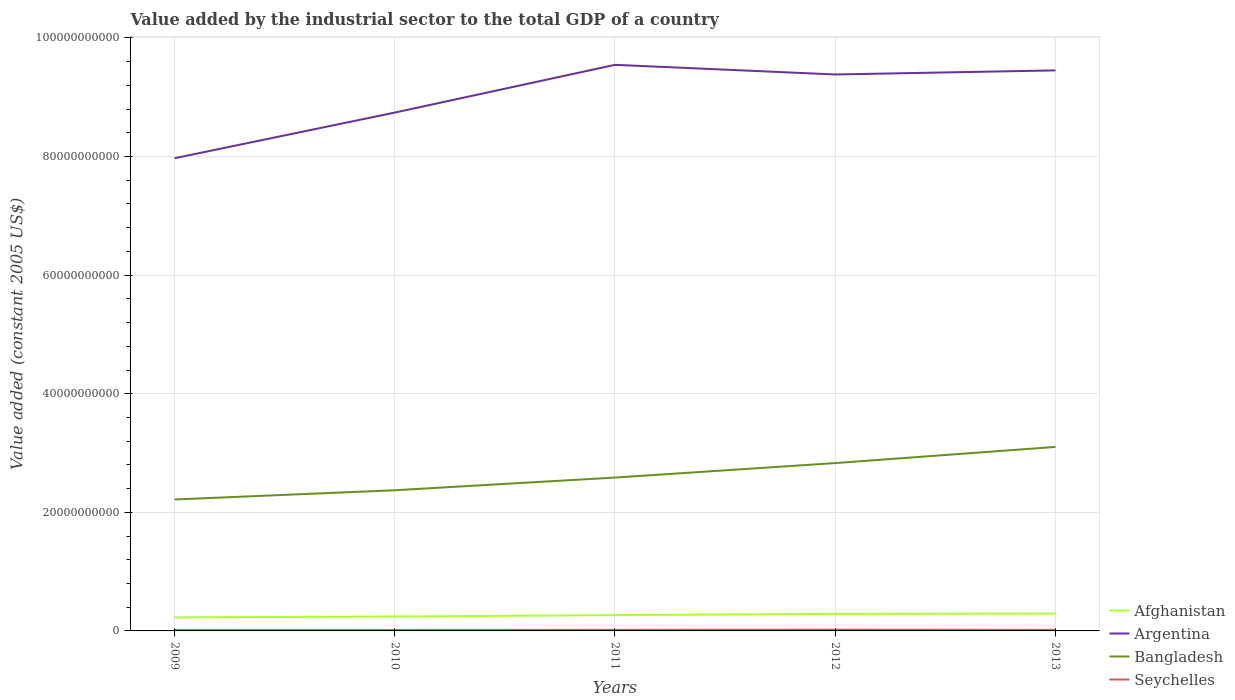How many different coloured lines are there?
Keep it short and to the point. 4. Across all years, what is the maximum value added by the industrial sector in Argentina?
Provide a short and direct response. 7.97e+1. In which year was the value added by the industrial sector in Bangladesh maximum?
Offer a terse response. 2009. What is the total value added by the industrial sector in Bangladesh in the graph?
Provide a succinct answer. -4.58e+09. What is the difference between the highest and the second highest value added by the industrial sector in Bangladesh?
Keep it short and to the point. 8.87e+09. How many years are there in the graph?
Provide a succinct answer. 5. Does the graph contain any zero values?
Your answer should be compact. No. Where does the legend appear in the graph?
Your response must be concise. Bottom right. How many legend labels are there?
Make the answer very short. 4. How are the legend labels stacked?
Make the answer very short. Vertical. What is the title of the graph?
Your answer should be compact. Value added by the industrial sector to the total GDP of a country. What is the label or title of the Y-axis?
Keep it short and to the point. Value added (constant 2005 US$). What is the Value added (constant 2005 US$) in Afghanistan in 2009?
Keep it short and to the point. 2.29e+09. What is the Value added (constant 2005 US$) in Argentina in 2009?
Your answer should be compact. 7.97e+1. What is the Value added (constant 2005 US$) of Bangladesh in 2009?
Give a very brief answer. 2.22e+1. What is the Value added (constant 2005 US$) in Seychelles in 2009?
Keep it short and to the point. 1.54e+08. What is the Value added (constant 2005 US$) in Afghanistan in 2010?
Your answer should be compact. 2.43e+09. What is the Value added (constant 2005 US$) of Argentina in 2010?
Your response must be concise. 8.74e+1. What is the Value added (constant 2005 US$) in Bangladesh in 2010?
Offer a terse response. 2.37e+1. What is the Value added (constant 2005 US$) in Seychelles in 2010?
Offer a very short reply. 1.59e+08. What is the Value added (constant 2005 US$) of Afghanistan in 2011?
Give a very brief answer. 2.67e+09. What is the Value added (constant 2005 US$) in Argentina in 2011?
Your answer should be very brief. 9.55e+1. What is the Value added (constant 2005 US$) in Bangladesh in 2011?
Keep it short and to the point. 2.59e+1. What is the Value added (constant 2005 US$) of Seychelles in 2011?
Ensure brevity in your answer.  1.84e+08. What is the Value added (constant 2005 US$) in Afghanistan in 2012?
Keep it short and to the point. 2.87e+09. What is the Value added (constant 2005 US$) of Argentina in 2012?
Your response must be concise. 9.38e+1. What is the Value added (constant 2005 US$) of Bangladesh in 2012?
Ensure brevity in your answer.  2.83e+1. What is the Value added (constant 2005 US$) in Seychelles in 2012?
Your answer should be compact. 2.18e+08. What is the Value added (constant 2005 US$) in Afghanistan in 2013?
Make the answer very short. 2.92e+09. What is the Value added (constant 2005 US$) of Argentina in 2013?
Your answer should be very brief. 9.45e+1. What is the Value added (constant 2005 US$) of Bangladesh in 2013?
Provide a succinct answer. 3.10e+1. What is the Value added (constant 2005 US$) in Seychelles in 2013?
Give a very brief answer. 1.75e+08. Across all years, what is the maximum Value added (constant 2005 US$) in Afghanistan?
Provide a succinct answer. 2.92e+09. Across all years, what is the maximum Value added (constant 2005 US$) of Argentina?
Give a very brief answer. 9.55e+1. Across all years, what is the maximum Value added (constant 2005 US$) in Bangladesh?
Your response must be concise. 3.10e+1. Across all years, what is the maximum Value added (constant 2005 US$) in Seychelles?
Your response must be concise. 2.18e+08. Across all years, what is the minimum Value added (constant 2005 US$) in Afghanistan?
Provide a short and direct response. 2.29e+09. Across all years, what is the minimum Value added (constant 2005 US$) in Argentina?
Your answer should be compact. 7.97e+1. Across all years, what is the minimum Value added (constant 2005 US$) in Bangladesh?
Offer a very short reply. 2.22e+1. Across all years, what is the minimum Value added (constant 2005 US$) of Seychelles?
Your answer should be very brief. 1.54e+08. What is the total Value added (constant 2005 US$) of Afghanistan in the graph?
Make the answer very short. 1.32e+1. What is the total Value added (constant 2005 US$) in Argentina in the graph?
Ensure brevity in your answer.  4.51e+11. What is the total Value added (constant 2005 US$) in Bangladesh in the graph?
Make the answer very short. 1.31e+11. What is the total Value added (constant 2005 US$) of Seychelles in the graph?
Offer a terse response. 8.90e+08. What is the difference between the Value added (constant 2005 US$) of Afghanistan in 2009 and that in 2010?
Your response must be concise. -1.43e+08. What is the difference between the Value added (constant 2005 US$) of Argentina in 2009 and that in 2010?
Provide a succinct answer. -7.70e+09. What is the difference between the Value added (constant 2005 US$) of Bangladesh in 2009 and that in 2010?
Your answer should be very brief. -1.56e+09. What is the difference between the Value added (constant 2005 US$) in Seychelles in 2009 and that in 2010?
Offer a very short reply. -5.25e+06. What is the difference between the Value added (constant 2005 US$) of Afghanistan in 2009 and that in 2011?
Your answer should be compact. -3.81e+08. What is the difference between the Value added (constant 2005 US$) in Argentina in 2009 and that in 2011?
Provide a short and direct response. -1.57e+1. What is the difference between the Value added (constant 2005 US$) of Bangladesh in 2009 and that in 2011?
Your response must be concise. -3.70e+09. What is the difference between the Value added (constant 2005 US$) of Seychelles in 2009 and that in 2011?
Your answer should be compact. -2.95e+07. What is the difference between the Value added (constant 2005 US$) in Afghanistan in 2009 and that in 2012?
Your answer should be very brief. -5.88e+08. What is the difference between the Value added (constant 2005 US$) in Argentina in 2009 and that in 2012?
Ensure brevity in your answer.  -1.41e+1. What is the difference between the Value added (constant 2005 US$) in Bangladesh in 2009 and that in 2012?
Your answer should be compact. -6.14e+09. What is the difference between the Value added (constant 2005 US$) of Seychelles in 2009 and that in 2012?
Provide a succinct answer. -6.41e+07. What is the difference between the Value added (constant 2005 US$) of Afghanistan in 2009 and that in 2013?
Your response must be concise. -6.38e+08. What is the difference between the Value added (constant 2005 US$) of Argentina in 2009 and that in 2013?
Ensure brevity in your answer.  -1.48e+1. What is the difference between the Value added (constant 2005 US$) in Bangladesh in 2009 and that in 2013?
Give a very brief answer. -8.87e+09. What is the difference between the Value added (constant 2005 US$) in Seychelles in 2009 and that in 2013?
Your response must be concise. -2.12e+07. What is the difference between the Value added (constant 2005 US$) of Afghanistan in 2010 and that in 2011?
Give a very brief answer. -2.38e+08. What is the difference between the Value added (constant 2005 US$) of Argentina in 2010 and that in 2011?
Your response must be concise. -8.05e+09. What is the difference between the Value added (constant 2005 US$) of Bangladesh in 2010 and that in 2011?
Provide a succinct answer. -2.14e+09. What is the difference between the Value added (constant 2005 US$) in Seychelles in 2010 and that in 2011?
Give a very brief answer. -2.43e+07. What is the difference between the Value added (constant 2005 US$) of Afghanistan in 2010 and that in 2012?
Provide a short and direct response. -4.45e+08. What is the difference between the Value added (constant 2005 US$) in Argentina in 2010 and that in 2012?
Give a very brief answer. -6.43e+09. What is the difference between the Value added (constant 2005 US$) of Bangladesh in 2010 and that in 2012?
Your answer should be compact. -4.58e+09. What is the difference between the Value added (constant 2005 US$) of Seychelles in 2010 and that in 2012?
Your response must be concise. -5.88e+07. What is the difference between the Value added (constant 2005 US$) in Afghanistan in 2010 and that in 2013?
Give a very brief answer. -4.95e+08. What is the difference between the Value added (constant 2005 US$) of Argentina in 2010 and that in 2013?
Ensure brevity in your answer.  -7.11e+09. What is the difference between the Value added (constant 2005 US$) of Bangladesh in 2010 and that in 2013?
Provide a succinct answer. -7.31e+09. What is the difference between the Value added (constant 2005 US$) of Seychelles in 2010 and that in 2013?
Keep it short and to the point. -1.59e+07. What is the difference between the Value added (constant 2005 US$) in Afghanistan in 2011 and that in 2012?
Make the answer very short. -2.07e+08. What is the difference between the Value added (constant 2005 US$) in Argentina in 2011 and that in 2012?
Keep it short and to the point. 1.63e+09. What is the difference between the Value added (constant 2005 US$) in Bangladesh in 2011 and that in 2012?
Give a very brief answer. -2.44e+09. What is the difference between the Value added (constant 2005 US$) of Seychelles in 2011 and that in 2012?
Ensure brevity in your answer.  -3.45e+07. What is the difference between the Value added (constant 2005 US$) of Afghanistan in 2011 and that in 2013?
Ensure brevity in your answer.  -2.57e+08. What is the difference between the Value added (constant 2005 US$) of Argentina in 2011 and that in 2013?
Keep it short and to the point. 9.36e+08. What is the difference between the Value added (constant 2005 US$) in Bangladesh in 2011 and that in 2013?
Provide a short and direct response. -5.17e+09. What is the difference between the Value added (constant 2005 US$) of Seychelles in 2011 and that in 2013?
Offer a terse response. 8.34e+06. What is the difference between the Value added (constant 2005 US$) in Afghanistan in 2012 and that in 2013?
Your answer should be very brief. -5.03e+07. What is the difference between the Value added (constant 2005 US$) in Argentina in 2012 and that in 2013?
Provide a short and direct response. -6.89e+08. What is the difference between the Value added (constant 2005 US$) of Bangladesh in 2012 and that in 2013?
Your answer should be very brief. -2.73e+09. What is the difference between the Value added (constant 2005 US$) in Seychelles in 2012 and that in 2013?
Your answer should be compact. 4.29e+07. What is the difference between the Value added (constant 2005 US$) in Afghanistan in 2009 and the Value added (constant 2005 US$) in Argentina in 2010?
Provide a short and direct response. -8.51e+1. What is the difference between the Value added (constant 2005 US$) of Afghanistan in 2009 and the Value added (constant 2005 US$) of Bangladesh in 2010?
Give a very brief answer. -2.14e+1. What is the difference between the Value added (constant 2005 US$) of Afghanistan in 2009 and the Value added (constant 2005 US$) of Seychelles in 2010?
Your answer should be very brief. 2.13e+09. What is the difference between the Value added (constant 2005 US$) of Argentina in 2009 and the Value added (constant 2005 US$) of Bangladesh in 2010?
Ensure brevity in your answer.  5.60e+1. What is the difference between the Value added (constant 2005 US$) of Argentina in 2009 and the Value added (constant 2005 US$) of Seychelles in 2010?
Provide a succinct answer. 7.96e+1. What is the difference between the Value added (constant 2005 US$) in Bangladesh in 2009 and the Value added (constant 2005 US$) in Seychelles in 2010?
Your response must be concise. 2.20e+1. What is the difference between the Value added (constant 2005 US$) of Afghanistan in 2009 and the Value added (constant 2005 US$) of Argentina in 2011?
Provide a short and direct response. -9.32e+1. What is the difference between the Value added (constant 2005 US$) in Afghanistan in 2009 and the Value added (constant 2005 US$) in Bangladesh in 2011?
Make the answer very short. -2.36e+1. What is the difference between the Value added (constant 2005 US$) in Afghanistan in 2009 and the Value added (constant 2005 US$) in Seychelles in 2011?
Provide a short and direct response. 2.10e+09. What is the difference between the Value added (constant 2005 US$) in Argentina in 2009 and the Value added (constant 2005 US$) in Bangladesh in 2011?
Offer a terse response. 5.39e+1. What is the difference between the Value added (constant 2005 US$) of Argentina in 2009 and the Value added (constant 2005 US$) of Seychelles in 2011?
Your response must be concise. 7.95e+1. What is the difference between the Value added (constant 2005 US$) of Bangladesh in 2009 and the Value added (constant 2005 US$) of Seychelles in 2011?
Provide a succinct answer. 2.20e+1. What is the difference between the Value added (constant 2005 US$) of Afghanistan in 2009 and the Value added (constant 2005 US$) of Argentina in 2012?
Make the answer very short. -9.16e+1. What is the difference between the Value added (constant 2005 US$) in Afghanistan in 2009 and the Value added (constant 2005 US$) in Bangladesh in 2012?
Keep it short and to the point. -2.60e+1. What is the difference between the Value added (constant 2005 US$) in Afghanistan in 2009 and the Value added (constant 2005 US$) in Seychelles in 2012?
Give a very brief answer. 2.07e+09. What is the difference between the Value added (constant 2005 US$) of Argentina in 2009 and the Value added (constant 2005 US$) of Bangladesh in 2012?
Make the answer very short. 5.14e+1. What is the difference between the Value added (constant 2005 US$) in Argentina in 2009 and the Value added (constant 2005 US$) in Seychelles in 2012?
Provide a succinct answer. 7.95e+1. What is the difference between the Value added (constant 2005 US$) in Bangladesh in 2009 and the Value added (constant 2005 US$) in Seychelles in 2012?
Give a very brief answer. 2.19e+1. What is the difference between the Value added (constant 2005 US$) of Afghanistan in 2009 and the Value added (constant 2005 US$) of Argentina in 2013?
Keep it short and to the point. -9.22e+1. What is the difference between the Value added (constant 2005 US$) in Afghanistan in 2009 and the Value added (constant 2005 US$) in Bangladesh in 2013?
Provide a short and direct response. -2.87e+1. What is the difference between the Value added (constant 2005 US$) in Afghanistan in 2009 and the Value added (constant 2005 US$) in Seychelles in 2013?
Your response must be concise. 2.11e+09. What is the difference between the Value added (constant 2005 US$) of Argentina in 2009 and the Value added (constant 2005 US$) of Bangladesh in 2013?
Ensure brevity in your answer.  4.87e+1. What is the difference between the Value added (constant 2005 US$) of Argentina in 2009 and the Value added (constant 2005 US$) of Seychelles in 2013?
Offer a terse response. 7.95e+1. What is the difference between the Value added (constant 2005 US$) of Bangladesh in 2009 and the Value added (constant 2005 US$) of Seychelles in 2013?
Your response must be concise. 2.20e+1. What is the difference between the Value added (constant 2005 US$) in Afghanistan in 2010 and the Value added (constant 2005 US$) in Argentina in 2011?
Your answer should be very brief. -9.30e+1. What is the difference between the Value added (constant 2005 US$) in Afghanistan in 2010 and the Value added (constant 2005 US$) in Bangladesh in 2011?
Provide a succinct answer. -2.34e+1. What is the difference between the Value added (constant 2005 US$) in Afghanistan in 2010 and the Value added (constant 2005 US$) in Seychelles in 2011?
Provide a short and direct response. 2.24e+09. What is the difference between the Value added (constant 2005 US$) of Argentina in 2010 and the Value added (constant 2005 US$) of Bangladesh in 2011?
Ensure brevity in your answer.  6.16e+1. What is the difference between the Value added (constant 2005 US$) of Argentina in 2010 and the Value added (constant 2005 US$) of Seychelles in 2011?
Keep it short and to the point. 8.72e+1. What is the difference between the Value added (constant 2005 US$) of Bangladesh in 2010 and the Value added (constant 2005 US$) of Seychelles in 2011?
Make the answer very short. 2.35e+1. What is the difference between the Value added (constant 2005 US$) of Afghanistan in 2010 and the Value added (constant 2005 US$) of Argentina in 2012?
Your answer should be very brief. -9.14e+1. What is the difference between the Value added (constant 2005 US$) in Afghanistan in 2010 and the Value added (constant 2005 US$) in Bangladesh in 2012?
Keep it short and to the point. -2.59e+1. What is the difference between the Value added (constant 2005 US$) in Afghanistan in 2010 and the Value added (constant 2005 US$) in Seychelles in 2012?
Your response must be concise. 2.21e+09. What is the difference between the Value added (constant 2005 US$) in Argentina in 2010 and the Value added (constant 2005 US$) in Bangladesh in 2012?
Provide a short and direct response. 5.91e+1. What is the difference between the Value added (constant 2005 US$) in Argentina in 2010 and the Value added (constant 2005 US$) in Seychelles in 2012?
Your answer should be very brief. 8.72e+1. What is the difference between the Value added (constant 2005 US$) in Bangladesh in 2010 and the Value added (constant 2005 US$) in Seychelles in 2012?
Offer a terse response. 2.35e+1. What is the difference between the Value added (constant 2005 US$) of Afghanistan in 2010 and the Value added (constant 2005 US$) of Argentina in 2013?
Your answer should be compact. -9.21e+1. What is the difference between the Value added (constant 2005 US$) of Afghanistan in 2010 and the Value added (constant 2005 US$) of Bangladesh in 2013?
Your answer should be compact. -2.86e+1. What is the difference between the Value added (constant 2005 US$) of Afghanistan in 2010 and the Value added (constant 2005 US$) of Seychelles in 2013?
Your answer should be very brief. 2.25e+09. What is the difference between the Value added (constant 2005 US$) in Argentina in 2010 and the Value added (constant 2005 US$) in Bangladesh in 2013?
Your answer should be very brief. 5.64e+1. What is the difference between the Value added (constant 2005 US$) of Argentina in 2010 and the Value added (constant 2005 US$) of Seychelles in 2013?
Give a very brief answer. 8.72e+1. What is the difference between the Value added (constant 2005 US$) of Bangladesh in 2010 and the Value added (constant 2005 US$) of Seychelles in 2013?
Offer a very short reply. 2.35e+1. What is the difference between the Value added (constant 2005 US$) in Afghanistan in 2011 and the Value added (constant 2005 US$) in Argentina in 2012?
Offer a very short reply. -9.12e+1. What is the difference between the Value added (constant 2005 US$) of Afghanistan in 2011 and the Value added (constant 2005 US$) of Bangladesh in 2012?
Give a very brief answer. -2.56e+1. What is the difference between the Value added (constant 2005 US$) of Afghanistan in 2011 and the Value added (constant 2005 US$) of Seychelles in 2012?
Your answer should be compact. 2.45e+09. What is the difference between the Value added (constant 2005 US$) in Argentina in 2011 and the Value added (constant 2005 US$) in Bangladesh in 2012?
Offer a terse response. 6.72e+1. What is the difference between the Value added (constant 2005 US$) of Argentina in 2011 and the Value added (constant 2005 US$) of Seychelles in 2012?
Make the answer very short. 9.52e+1. What is the difference between the Value added (constant 2005 US$) in Bangladesh in 2011 and the Value added (constant 2005 US$) in Seychelles in 2012?
Your answer should be very brief. 2.56e+1. What is the difference between the Value added (constant 2005 US$) in Afghanistan in 2011 and the Value added (constant 2005 US$) in Argentina in 2013?
Offer a terse response. -9.19e+1. What is the difference between the Value added (constant 2005 US$) in Afghanistan in 2011 and the Value added (constant 2005 US$) in Bangladesh in 2013?
Offer a terse response. -2.84e+1. What is the difference between the Value added (constant 2005 US$) in Afghanistan in 2011 and the Value added (constant 2005 US$) in Seychelles in 2013?
Offer a terse response. 2.49e+09. What is the difference between the Value added (constant 2005 US$) in Argentina in 2011 and the Value added (constant 2005 US$) in Bangladesh in 2013?
Your response must be concise. 6.44e+1. What is the difference between the Value added (constant 2005 US$) of Argentina in 2011 and the Value added (constant 2005 US$) of Seychelles in 2013?
Keep it short and to the point. 9.53e+1. What is the difference between the Value added (constant 2005 US$) of Bangladesh in 2011 and the Value added (constant 2005 US$) of Seychelles in 2013?
Provide a succinct answer. 2.57e+1. What is the difference between the Value added (constant 2005 US$) of Afghanistan in 2012 and the Value added (constant 2005 US$) of Argentina in 2013?
Provide a short and direct response. -9.17e+1. What is the difference between the Value added (constant 2005 US$) of Afghanistan in 2012 and the Value added (constant 2005 US$) of Bangladesh in 2013?
Provide a short and direct response. -2.82e+1. What is the difference between the Value added (constant 2005 US$) of Afghanistan in 2012 and the Value added (constant 2005 US$) of Seychelles in 2013?
Make the answer very short. 2.70e+09. What is the difference between the Value added (constant 2005 US$) of Argentina in 2012 and the Value added (constant 2005 US$) of Bangladesh in 2013?
Provide a succinct answer. 6.28e+1. What is the difference between the Value added (constant 2005 US$) of Argentina in 2012 and the Value added (constant 2005 US$) of Seychelles in 2013?
Ensure brevity in your answer.  9.37e+1. What is the difference between the Value added (constant 2005 US$) of Bangladesh in 2012 and the Value added (constant 2005 US$) of Seychelles in 2013?
Make the answer very short. 2.81e+1. What is the average Value added (constant 2005 US$) of Afghanistan per year?
Make the answer very short. 2.64e+09. What is the average Value added (constant 2005 US$) of Argentina per year?
Offer a very short reply. 9.02e+1. What is the average Value added (constant 2005 US$) of Bangladesh per year?
Provide a succinct answer. 2.62e+1. What is the average Value added (constant 2005 US$) in Seychelles per year?
Provide a short and direct response. 1.78e+08. In the year 2009, what is the difference between the Value added (constant 2005 US$) of Afghanistan and Value added (constant 2005 US$) of Argentina?
Make the answer very short. -7.74e+1. In the year 2009, what is the difference between the Value added (constant 2005 US$) of Afghanistan and Value added (constant 2005 US$) of Bangladesh?
Offer a very short reply. -1.99e+1. In the year 2009, what is the difference between the Value added (constant 2005 US$) in Afghanistan and Value added (constant 2005 US$) in Seychelles?
Your answer should be very brief. 2.13e+09. In the year 2009, what is the difference between the Value added (constant 2005 US$) of Argentina and Value added (constant 2005 US$) of Bangladesh?
Give a very brief answer. 5.76e+1. In the year 2009, what is the difference between the Value added (constant 2005 US$) of Argentina and Value added (constant 2005 US$) of Seychelles?
Keep it short and to the point. 7.96e+1. In the year 2009, what is the difference between the Value added (constant 2005 US$) in Bangladesh and Value added (constant 2005 US$) in Seychelles?
Offer a terse response. 2.20e+1. In the year 2010, what is the difference between the Value added (constant 2005 US$) in Afghanistan and Value added (constant 2005 US$) in Argentina?
Make the answer very short. -8.50e+1. In the year 2010, what is the difference between the Value added (constant 2005 US$) in Afghanistan and Value added (constant 2005 US$) in Bangladesh?
Give a very brief answer. -2.13e+1. In the year 2010, what is the difference between the Value added (constant 2005 US$) in Afghanistan and Value added (constant 2005 US$) in Seychelles?
Offer a very short reply. 2.27e+09. In the year 2010, what is the difference between the Value added (constant 2005 US$) in Argentina and Value added (constant 2005 US$) in Bangladesh?
Give a very brief answer. 6.37e+1. In the year 2010, what is the difference between the Value added (constant 2005 US$) of Argentina and Value added (constant 2005 US$) of Seychelles?
Offer a very short reply. 8.73e+1. In the year 2010, what is the difference between the Value added (constant 2005 US$) of Bangladesh and Value added (constant 2005 US$) of Seychelles?
Offer a very short reply. 2.36e+1. In the year 2011, what is the difference between the Value added (constant 2005 US$) in Afghanistan and Value added (constant 2005 US$) in Argentina?
Provide a short and direct response. -9.28e+1. In the year 2011, what is the difference between the Value added (constant 2005 US$) of Afghanistan and Value added (constant 2005 US$) of Bangladesh?
Provide a short and direct response. -2.32e+1. In the year 2011, what is the difference between the Value added (constant 2005 US$) of Afghanistan and Value added (constant 2005 US$) of Seychelles?
Give a very brief answer. 2.48e+09. In the year 2011, what is the difference between the Value added (constant 2005 US$) in Argentina and Value added (constant 2005 US$) in Bangladesh?
Your answer should be very brief. 6.96e+1. In the year 2011, what is the difference between the Value added (constant 2005 US$) in Argentina and Value added (constant 2005 US$) in Seychelles?
Provide a succinct answer. 9.53e+1. In the year 2011, what is the difference between the Value added (constant 2005 US$) of Bangladesh and Value added (constant 2005 US$) of Seychelles?
Keep it short and to the point. 2.57e+1. In the year 2012, what is the difference between the Value added (constant 2005 US$) of Afghanistan and Value added (constant 2005 US$) of Argentina?
Your response must be concise. -9.10e+1. In the year 2012, what is the difference between the Value added (constant 2005 US$) in Afghanistan and Value added (constant 2005 US$) in Bangladesh?
Your response must be concise. -2.54e+1. In the year 2012, what is the difference between the Value added (constant 2005 US$) of Afghanistan and Value added (constant 2005 US$) of Seychelles?
Provide a short and direct response. 2.66e+09. In the year 2012, what is the difference between the Value added (constant 2005 US$) in Argentina and Value added (constant 2005 US$) in Bangladesh?
Your answer should be compact. 6.55e+1. In the year 2012, what is the difference between the Value added (constant 2005 US$) in Argentina and Value added (constant 2005 US$) in Seychelles?
Your response must be concise. 9.36e+1. In the year 2012, what is the difference between the Value added (constant 2005 US$) in Bangladesh and Value added (constant 2005 US$) in Seychelles?
Your answer should be compact. 2.81e+1. In the year 2013, what is the difference between the Value added (constant 2005 US$) in Afghanistan and Value added (constant 2005 US$) in Argentina?
Offer a terse response. -9.16e+1. In the year 2013, what is the difference between the Value added (constant 2005 US$) of Afghanistan and Value added (constant 2005 US$) of Bangladesh?
Provide a succinct answer. -2.81e+1. In the year 2013, what is the difference between the Value added (constant 2005 US$) of Afghanistan and Value added (constant 2005 US$) of Seychelles?
Offer a terse response. 2.75e+09. In the year 2013, what is the difference between the Value added (constant 2005 US$) of Argentina and Value added (constant 2005 US$) of Bangladesh?
Offer a terse response. 6.35e+1. In the year 2013, what is the difference between the Value added (constant 2005 US$) of Argentina and Value added (constant 2005 US$) of Seychelles?
Your answer should be very brief. 9.44e+1. In the year 2013, what is the difference between the Value added (constant 2005 US$) of Bangladesh and Value added (constant 2005 US$) of Seychelles?
Your response must be concise. 3.09e+1. What is the ratio of the Value added (constant 2005 US$) of Afghanistan in 2009 to that in 2010?
Make the answer very short. 0.94. What is the ratio of the Value added (constant 2005 US$) in Argentina in 2009 to that in 2010?
Provide a succinct answer. 0.91. What is the ratio of the Value added (constant 2005 US$) in Bangladesh in 2009 to that in 2010?
Offer a terse response. 0.93. What is the ratio of the Value added (constant 2005 US$) in Seychelles in 2009 to that in 2010?
Give a very brief answer. 0.97. What is the ratio of the Value added (constant 2005 US$) of Afghanistan in 2009 to that in 2011?
Your answer should be compact. 0.86. What is the ratio of the Value added (constant 2005 US$) in Argentina in 2009 to that in 2011?
Offer a very short reply. 0.83. What is the ratio of the Value added (constant 2005 US$) of Bangladesh in 2009 to that in 2011?
Keep it short and to the point. 0.86. What is the ratio of the Value added (constant 2005 US$) in Seychelles in 2009 to that in 2011?
Offer a terse response. 0.84. What is the ratio of the Value added (constant 2005 US$) in Afghanistan in 2009 to that in 2012?
Keep it short and to the point. 0.8. What is the ratio of the Value added (constant 2005 US$) of Argentina in 2009 to that in 2012?
Provide a succinct answer. 0.85. What is the ratio of the Value added (constant 2005 US$) of Bangladesh in 2009 to that in 2012?
Your answer should be very brief. 0.78. What is the ratio of the Value added (constant 2005 US$) in Seychelles in 2009 to that in 2012?
Your answer should be compact. 0.71. What is the ratio of the Value added (constant 2005 US$) of Afghanistan in 2009 to that in 2013?
Your response must be concise. 0.78. What is the ratio of the Value added (constant 2005 US$) of Argentina in 2009 to that in 2013?
Ensure brevity in your answer.  0.84. What is the ratio of the Value added (constant 2005 US$) of Bangladesh in 2009 to that in 2013?
Give a very brief answer. 0.71. What is the ratio of the Value added (constant 2005 US$) of Seychelles in 2009 to that in 2013?
Your answer should be compact. 0.88. What is the ratio of the Value added (constant 2005 US$) in Afghanistan in 2010 to that in 2011?
Your answer should be compact. 0.91. What is the ratio of the Value added (constant 2005 US$) in Argentina in 2010 to that in 2011?
Offer a terse response. 0.92. What is the ratio of the Value added (constant 2005 US$) in Bangladesh in 2010 to that in 2011?
Make the answer very short. 0.92. What is the ratio of the Value added (constant 2005 US$) of Seychelles in 2010 to that in 2011?
Ensure brevity in your answer.  0.87. What is the ratio of the Value added (constant 2005 US$) of Afghanistan in 2010 to that in 2012?
Offer a very short reply. 0.85. What is the ratio of the Value added (constant 2005 US$) in Argentina in 2010 to that in 2012?
Your answer should be compact. 0.93. What is the ratio of the Value added (constant 2005 US$) of Bangladesh in 2010 to that in 2012?
Your answer should be very brief. 0.84. What is the ratio of the Value added (constant 2005 US$) in Seychelles in 2010 to that in 2012?
Make the answer very short. 0.73. What is the ratio of the Value added (constant 2005 US$) in Afghanistan in 2010 to that in 2013?
Provide a short and direct response. 0.83. What is the ratio of the Value added (constant 2005 US$) of Argentina in 2010 to that in 2013?
Your response must be concise. 0.92. What is the ratio of the Value added (constant 2005 US$) in Bangladesh in 2010 to that in 2013?
Offer a very short reply. 0.76. What is the ratio of the Value added (constant 2005 US$) of Seychelles in 2010 to that in 2013?
Your response must be concise. 0.91. What is the ratio of the Value added (constant 2005 US$) in Afghanistan in 2011 to that in 2012?
Offer a terse response. 0.93. What is the ratio of the Value added (constant 2005 US$) in Argentina in 2011 to that in 2012?
Provide a succinct answer. 1.02. What is the ratio of the Value added (constant 2005 US$) of Bangladesh in 2011 to that in 2012?
Provide a succinct answer. 0.91. What is the ratio of the Value added (constant 2005 US$) of Seychelles in 2011 to that in 2012?
Make the answer very short. 0.84. What is the ratio of the Value added (constant 2005 US$) of Afghanistan in 2011 to that in 2013?
Ensure brevity in your answer.  0.91. What is the ratio of the Value added (constant 2005 US$) of Argentina in 2011 to that in 2013?
Your answer should be compact. 1.01. What is the ratio of the Value added (constant 2005 US$) in Bangladesh in 2011 to that in 2013?
Keep it short and to the point. 0.83. What is the ratio of the Value added (constant 2005 US$) of Seychelles in 2011 to that in 2013?
Ensure brevity in your answer.  1.05. What is the ratio of the Value added (constant 2005 US$) in Afghanistan in 2012 to that in 2013?
Provide a short and direct response. 0.98. What is the ratio of the Value added (constant 2005 US$) in Argentina in 2012 to that in 2013?
Offer a terse response. 0.99. What is the ratio of the Value added (constant 2005 US$) in Bangladesh in 2012 to that in 2013?
Ensure brevity in your answer.  0.91. What is the ratio of the Value added (constant 2005 US$) in Seychelles in 2012 to that in 2013?
Make the answer very short. 1.24. What is the difference between the highest and the second highest Value added (constant 2005 US$) in Afghanistan?
Offer a very short reply. 5.03e+07. What is the difference between the highest and the second highest Value added (constant 2005 US$) in Argentina?
Keep it short and to the point. 9.36e+08. What is the difference between the highest and the second highest Value added (constant 2005 US$) in Bangladesh?
Make the answer very short. 2.73e+09. What is the difference between the highest and the second highest Value added (constant 2005 US$) in Seychelles?
Provide a short and direct response. 3.45e+07. What is the difference between the highest and the lowest Value added (constant 2005 US$) in Afghanistan?
Ensure brevity in your answer.  6.38e+08. What is the difference between the highest and the lowest Value added (constant 2005 US$) in Argentina?
Provide a succinct answer. 1.57e+1. What is the difference between the highest and the lowest Value added (constant 2005 US$) in Bangladesh?
Provide a short and direct response. 8.87e+09. What is the difference between the highest and the lowest Value added (constant 2005 US$) of Seychelles?
Offer a very short reply. 6.41e+07. 